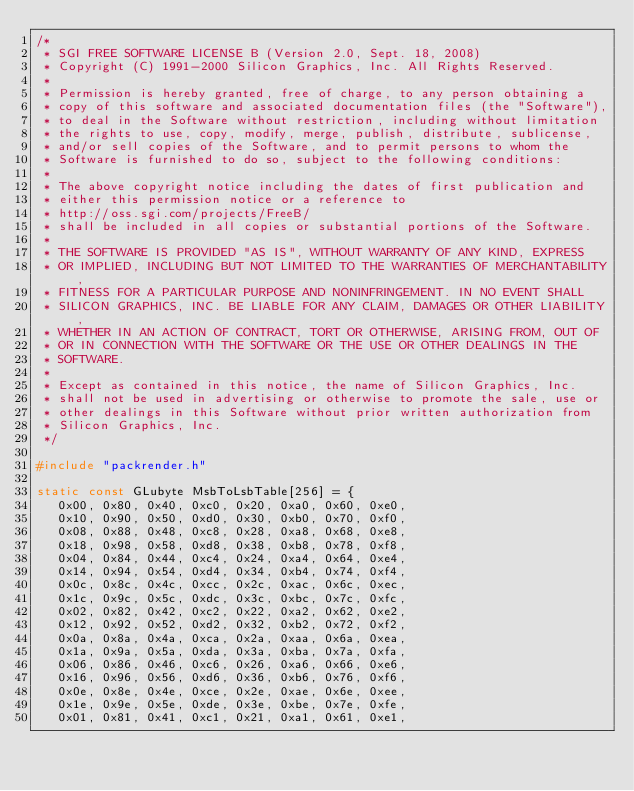Convert code to text. <code><loc_0><loc_0><loc_500><loc_500><_C_>/*
 * SGI FREE SOFTWARE LICENSE B (Version 2.0, Sept. 18, 2008)
 * Copyright (C) 1991-2000 Silicon Graphics, Inc. All Rights Reserved.
 *
 * Permission is hereby granted, free of charge, to any person obtaining a
 * copy of this software and associated documentation files (the "Software"),
 * to deal in the Software without restriction, including without limitation
 * the rights to use, copy, modify, merge, publish, distribute, sublicense,
 * and/or sell copies of the Software, and to permit persons to whom the
 * Software is furnished to do so, subject to the following conditions:
 *
 * The above copyright notice including the dates of first publication and
 * either this permission notice or a reference to
 * http://oss.sgi.com/projects/FreeB/
 * shall be included in all copies or substantial portions of the Software.
 *
 * THE SOFTWARE IS PROVIDED "AS IS", WITHOUT WARRANTY OF ANY KIND, EXPRESS
 * OR IMPLIED, INCLUDING BUT NOT LIMITED TO THE WARRANTIES OF MERCHANTABILITY,
 * FITNESS FOR A PARTICULAR PURPOSE AND NONINFRINGEMENT. IN NO EVENT SHALL
 * SILICON GRAPHICS, INC. BE LIABLE FOR ANY CLAIM, DAMAGES OR OTHER LIABILITY,
 * WHETHER IN AN ACTION OF CONTRACT, TORT OR OTHERWISE, ARISING FROM, OUT OF
 * OR IN CONNECTION WITH THE SOFTWARE OR THE USE OR OTHER DEALINGS IN THE
 * SOFTWARE.
 *
 * Except as contained in this notice, the name of Silicon Graphics, Inc.
 * shall not be used in advertising or otherwise to promote the sale, use or
 * other dealings in this Software without prior written authorization from
 * Silicon Graphics, Inc.
 */

#include "packrender.h"

static const GLubyte MsbToLsbTable[256] = {
   0x00, 0x80, 0x40, 0xc0, 0x20, 0xa0, 0x60, 0xe0,
   0x10, 0x90, 0x50, 0xd0, 0x30, 0xb0, 0x70, 0xf0,
   0x08, 0x88, 0x48, 0xc8, 0x28, 0xa8, 0x68, 0xe8,
   0x18, 0x98, 0x58, 0xd8, 0x38, 0xb8, 0x78, 0xf8,
   0x04, 0x84, 0x44, 0xc4, 0x24, 0xa4, 0x64, 0xe4,
   0x14, 0x94, 0x54, 0xd4, 0x34, 0xb4, 0x74, 0xf4,
   0x0c, 0x8c, 0x4c, 0xcc, 0x2c, 0xac, 0x6c, 0xec,
   0x1c, 0x9c, 0x5c, 0xdc, 0x3c, 0xbc, 0x7c, 0xfc,
   0x02, 0x82, 0x42, 0xc2, 0x22, 0xa2, 0x62, 0xe2,
   0x12, 0x92, 0x52, 0xd2, 0x32, 0xb2, 0x72, 0xf2,
   0x0a, 0x8a, 0x4a, 0xca, 0x2a, 0xaa, 0x6a, 0xea,
   0x1a, 0x9a, 0x5a, 0xda, 0x3a, 0xba, 0x7a, 0xfa,
   0x06, 0x86, 0x46, 0xc6, 0x26, 0xa6, 0x66, 0xe6,
   0x16, 0x96, 0x56, 0xd6, 0x36, 0xb6, 0x76, 0xf6,
   0x0e, 0x8e, 0x4e, 0xce, 0x2e, 0xae, 0x6e, 0xee,
   0x1e, 0x9e, 0x5e, 0xde, 0x3e, 0xbe, 0x7e, 0xfe,
   0x01, 0x81, 0x41, 0xc1, 0x21, 0xa1, 0x61, 0xe1,</code> 